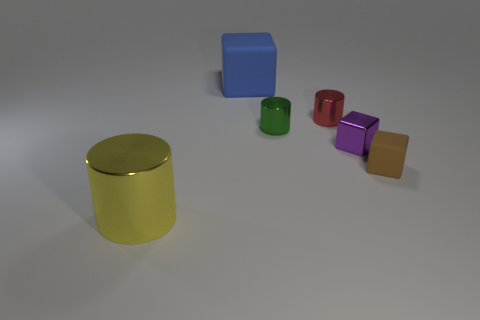What shape is the small red thing that is the same material as the tiny green cylinder?
Offer a very short reply. Cylinder. Is there any other thing that has the same shape as the green metal thing?
Make the answer very short. Yes. There is a big object that is in front of the blue object; what is it made of?
Offer a terse response. Metal. Are there any other things that are the same size as the blue matte block?
Give a very brief answer. Yes. There is a small matte block; are there any small metal objects in front of it?
Offer a very short reply. No. The blue matte object is what shape?
Offer a very short reply. Cube. What number of objects are cylinders behind the large yellow cylinder or tiny cylinders?
Your answer should be very brief. 2. Does the large metal cylinder have the same color as the matte block that is on the right side of the big block?
Offer a very short reply. No. There is a shiny object that is the same shape as the brown matte object; what is its color?
Your answer should be very brief. Purple. Is the yellow object made of the same material as the tiny block that is behind the tiny brown thing?
Your response must be concise. Yes. 